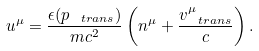<formula> <loc_0><loc_0><loc_500><loc_500>u ^ { \mu } = \frac { \epsilon ( p _ { \ t r a n s } ) } { m c ^ { 2 } } \left ( n ^ { \mu } + \frac { v ^ { \mu } _ { \ t r a n s } } { c } \right ) .</formula> 